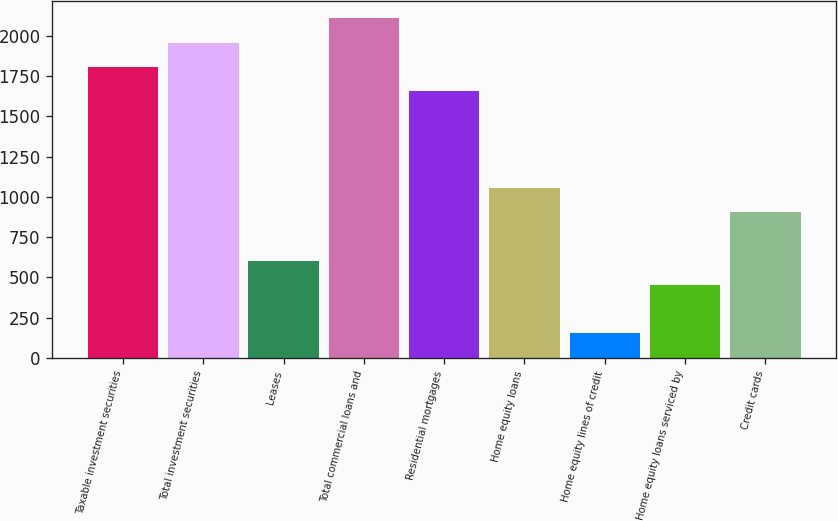Convert chart to OTSL. <chart><loc_0><loc_0><loc_500><loc_500><bar_chart><fcel>Taxable investment securities<fcel>Total investment securities<fcel>Leases<fcel>Total commercial loans and<fcel>Residential mortgages<fcel>Home equity loans<fcel>Home equity lines of credit<fcel>Home equity loans serviced by<fcel>Credit cards<nl><fcel>1808<fcel>1958.5<fcel>604<fcel>2109<fcel>1657.5<fcel>1055.5<fcel>152.5<fcel>453.5<fcel>905<nl></chart> 